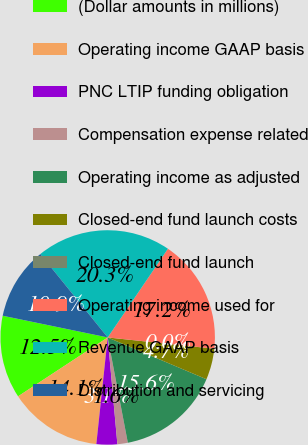Convert chart to OTSL. <chart><loc_0><loc_0><loc_500><loc_500><pie_chart><fcel>(Dollar amounts in millions)<fcel>Operating income GAAP basis<fcel>PNC LTIP funding obligation<fcel>Compensation expense related<fcel>Operating income as adjusted<fcel>Closed-end fund launch costs<fcel>Closed-end fund launch<fcel>Operating income used for<fcel>Revenue GAAP basis<fcel>Distribution and servicing<nl><fcel>12.5%<fcel>14.06%<fcel>3.13%<fcel>1.57%<fcel>15.62%<fcel>4.69%<fcel>0.01%<fcel>17.18%<fcel>20.31%<fcel>10.94%<nl></chart> 